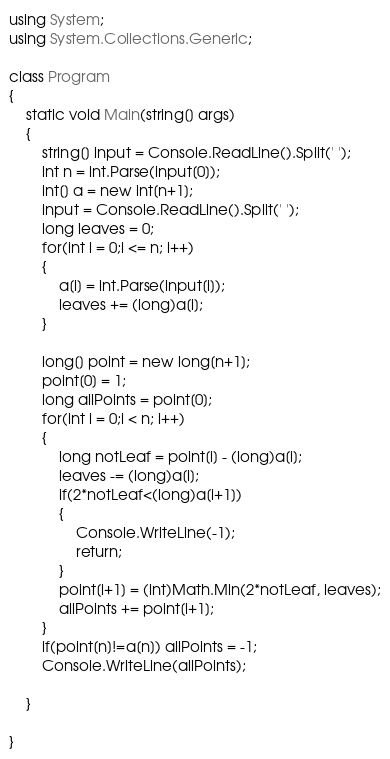<code> <loc_0><loc_0><loc_500><loc_500><_C#_>using System;
using System.Collections.Generic;

class Program
{
	static void Main(string[] args)
	{
		string[] input = Console.ReadLine().Split(' ');
		int n = int.Parse(input[0]);
		int[] a = new int[n+1];
		input = Console.ReadLine().Split(' ');
		long leaves = 0;
		for(int i = 0;i <= n; i++)
		{
			a[i] = int.Parse(input[i]);
			leaves += (long)a[i];
		}

		long[] point = new long[n+1];
		point[0] = 1;
		long allPoints = point[0];
		for(int i = 0;i < n; i++)
		{
			long notLeaf = point[i] - (long)a[i];
			leaves -= (long)a[i];
			if(2*notLeaf<(long)a[i+1])
			{
				Console.WriteLine(-1);
				return;
			}
			point[i+1] = (int)Math.Min(2*notLeaf, leaves);
			allPoints += point[i+1];
		}
		if(point[n]!=a[n]) allPoints = -1;
		Console.WriteLine(allPoints);

	}

}
</code> 